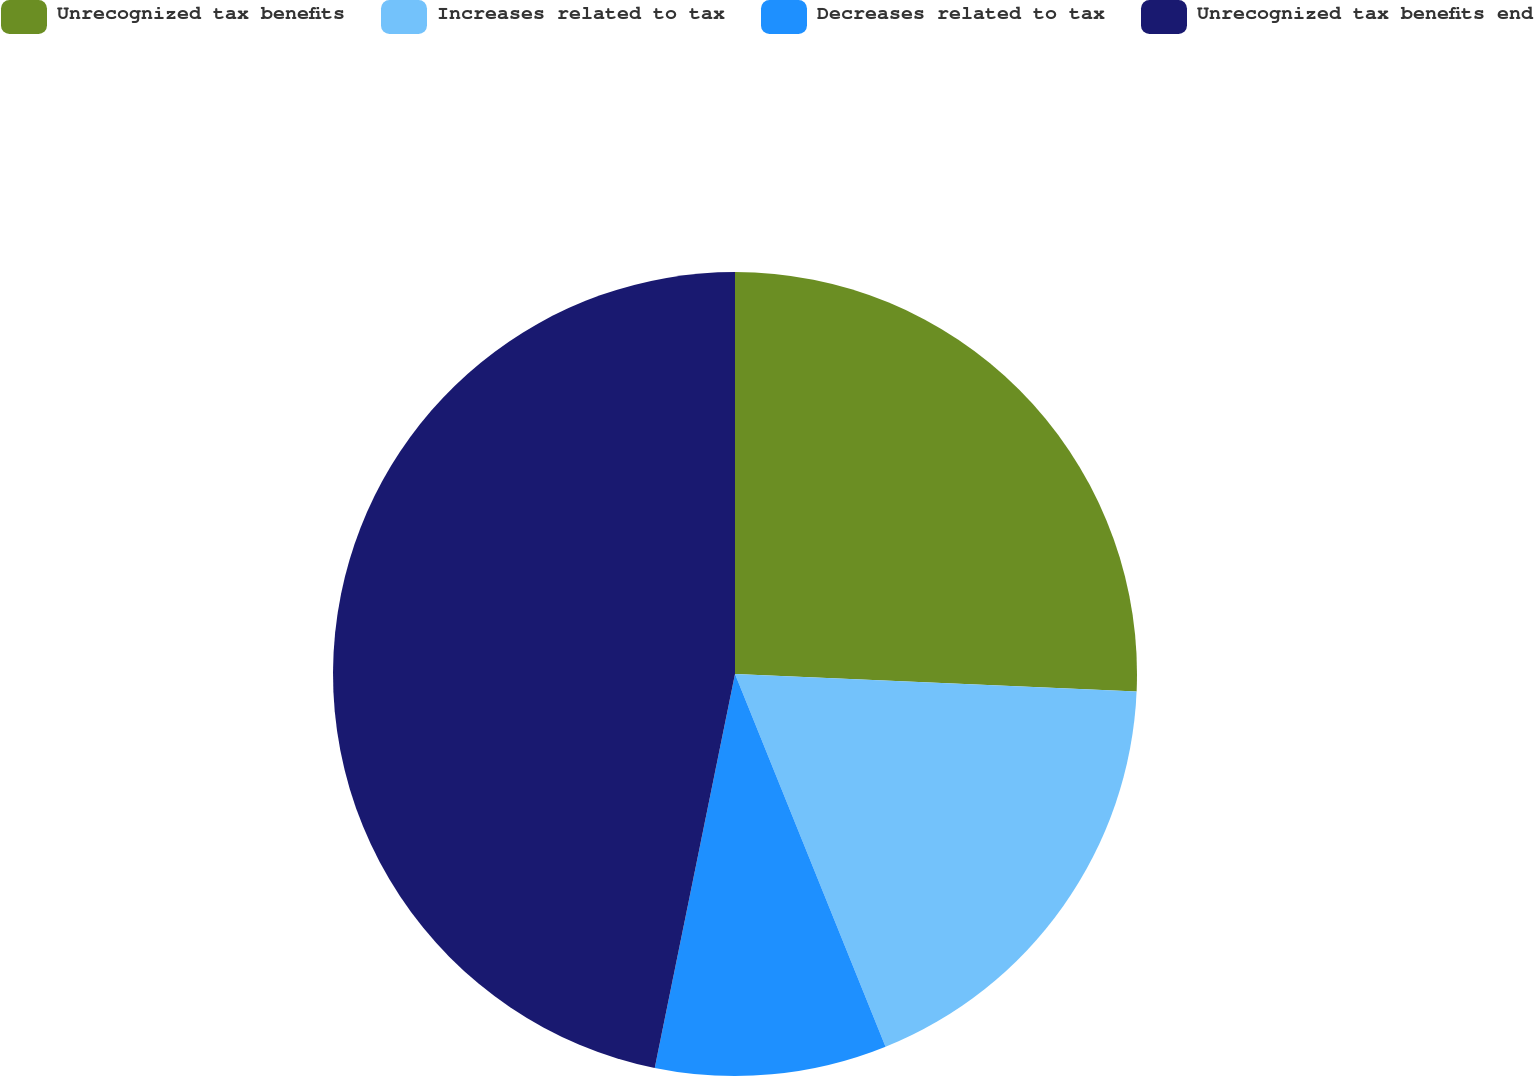Convert chart. <chart><loc_0><loc_0><loc_500><loc_500><pie_chart><fcel>Unrecognized tax benefits<fcel>Increases related to tax<fcel>Decreases related to tax<fcel>Unrecognized tax benefits end<nl><fcel>25.69%<fcel>18.2%<fcel>9.31%<fcel>46.8%<nl></chart> 